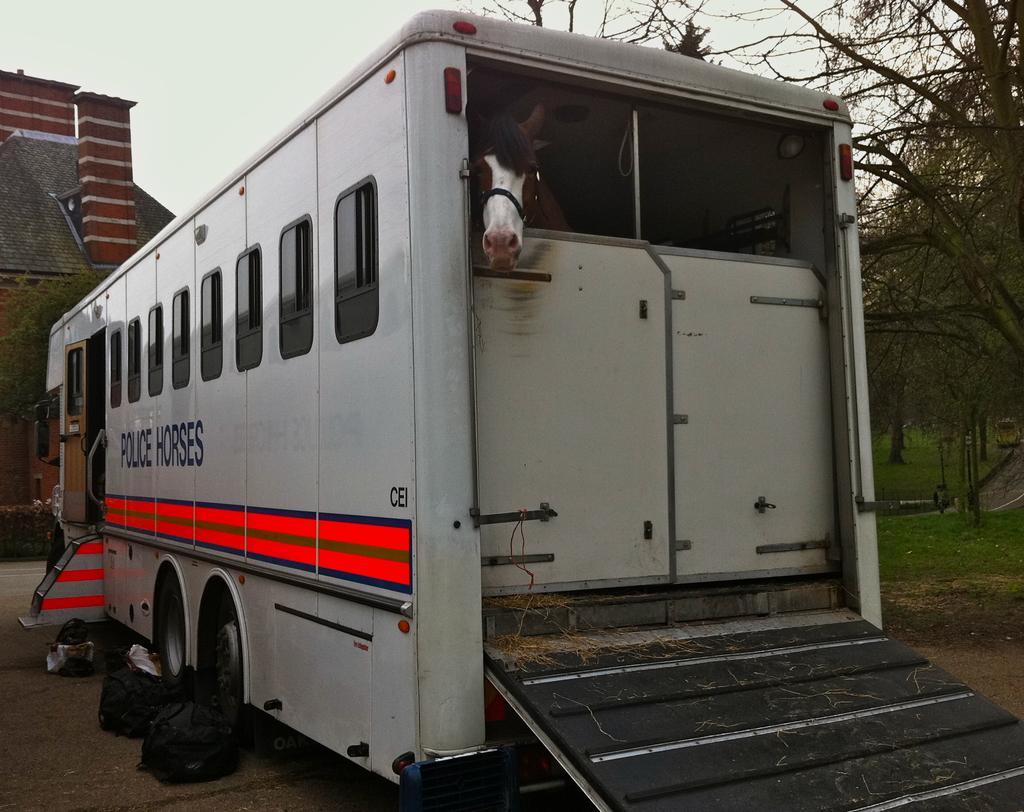Could you give a brief overview of what you see in this image? In this picture we can observe a vehicle. There is a horse inside the vehicle. This vehicle is on the road. We can observe black color bags beside the vehicle. In the background there is a building. We can observe some trees and a sky. 